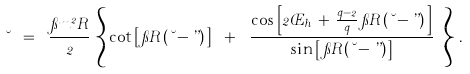<formula> <loc_0><loc_0><loc_500><loc_500>\lambda \ = \ \frac { \pi m ^ { 2 } R } { 2 } \, \left \{ \, \cot \left [ \, \pi R \, ( \lambda - \varepsilon ) \, \right ] \ + \ \frac { \cos \left [ 2 \phi _ { h } \, + \, \frac { q - 2 } { q } \, \pi R \, ( \lambda - \varepsilon ) \, \right ] } { \sin \left [ \, \pi R \, ( \lambda - \varepsilon ) \, \right ] } \ \right \} \, .</formula> 